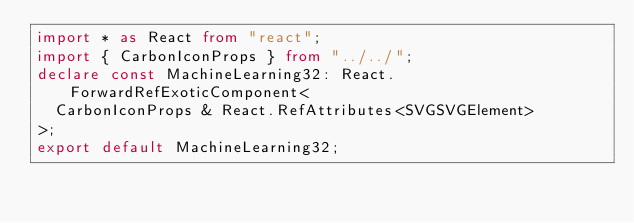<code> <loc_0><loc_0><loc_500><loc_500><_TypeScript_>import * as React from "react";
import { CarbonIconProps } from "../../";
declare const MachineLearning32: React.ForwardRefExoticComponent<
  CarbonIconProps & React.RefAttributes<SVGSVGElement>
>;
export default MachineLearning32;
</code> 